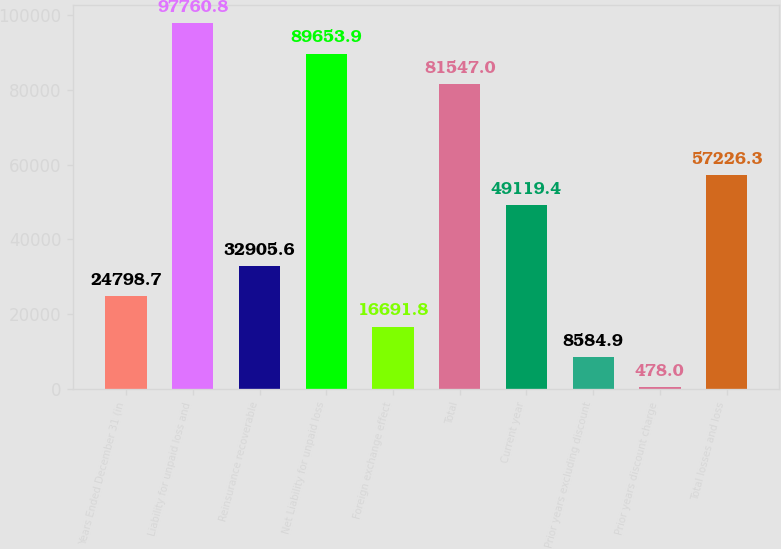<chart> <loc_0><loc_0><loc_500><loc_500><bar_chart><fcel>Years Ended December 31 (in<fcel>Liability for unpaid loss and<fcel>Reinsurance recoverable<fcel>Net Liability for unpaid loss<fcel>Foreign exchange effect<fcel>Total<fcel>Current year<fcel>Prior years excluding discount<fcel>Prior years discount charge<fcel>Total losses and loss<nl><fcel>24798.7<fcel>97760.8<fcel>32905.6<fcel>89653.9<fcel>16691.8<fcel>81547<fcel>49119.4<fcel>8584.9<fcel>478<fcel>57226.3<nl></chart> 